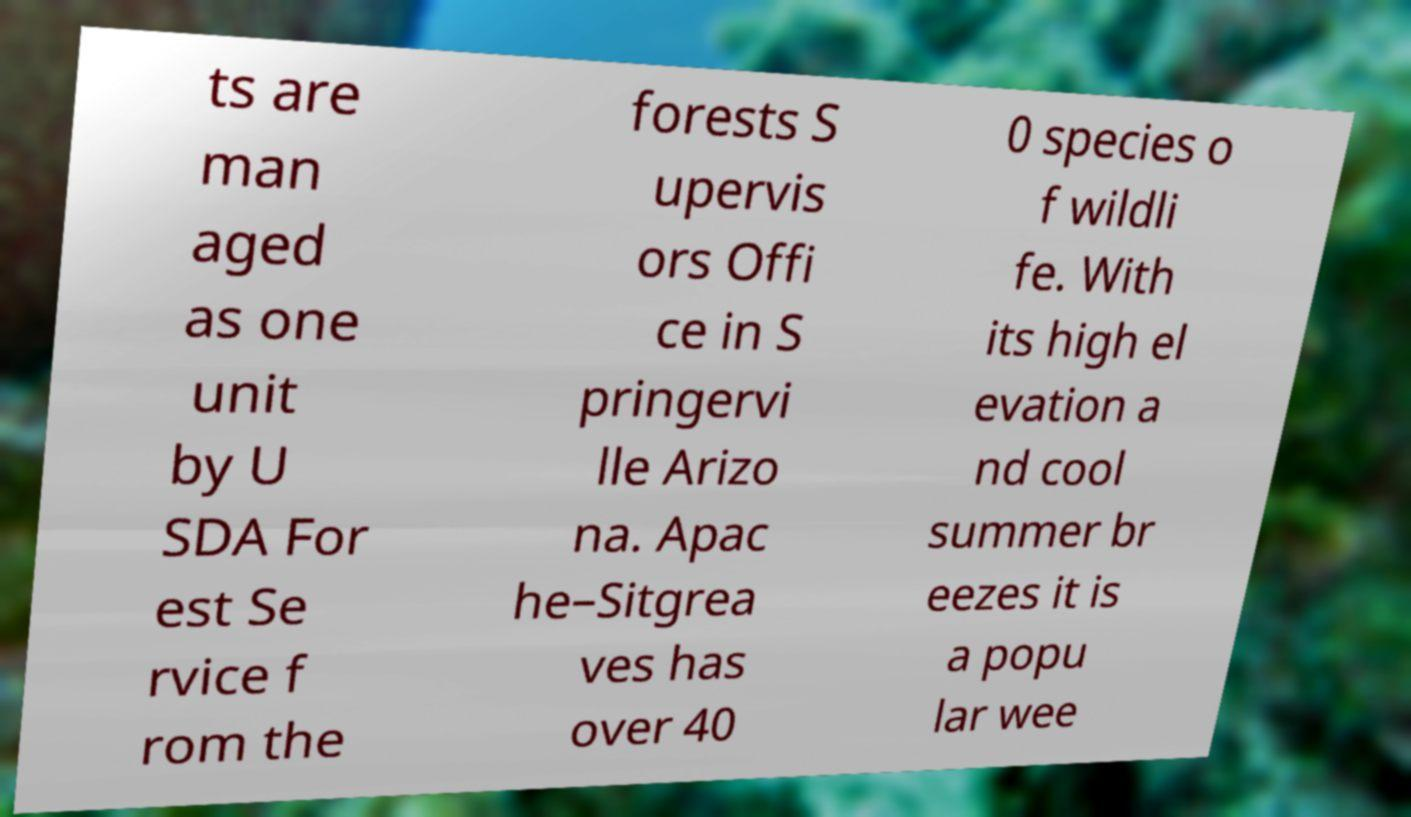Can you read and provide the text displayed in the image?This photo seems to have some interesting text. Can you extract and type it out for me? ts are man aged as one unit by U SDA For est Se rvice f rom the forests S upervis ors Offi ce in S pringervi lle Arizo na. Apac he–Sitgrea ves has over 40 0 species o f wildli fe. With its high el evation a nd cool summer br eezes it is a popu lar wee 